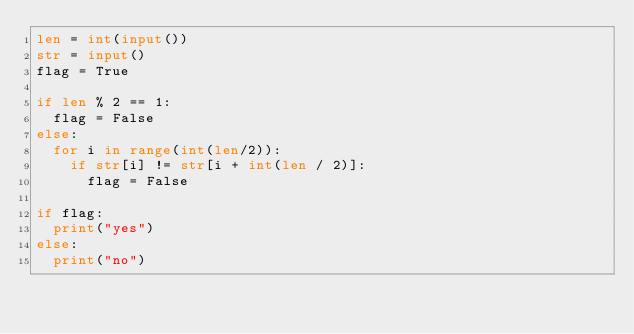Convert code to text. <code><loc_0><loc_0><loc_500><loc_500><_Python_>len = int(input())
str = input()
flag = True

if len % 2 == 1:
  flag = False
else:
  for i in range(int(len/2)):
    if str[i] != str[i + int(len / 2)]:
      flag = False

if flag:
  print("yes")
else:
  print("no")</code> 